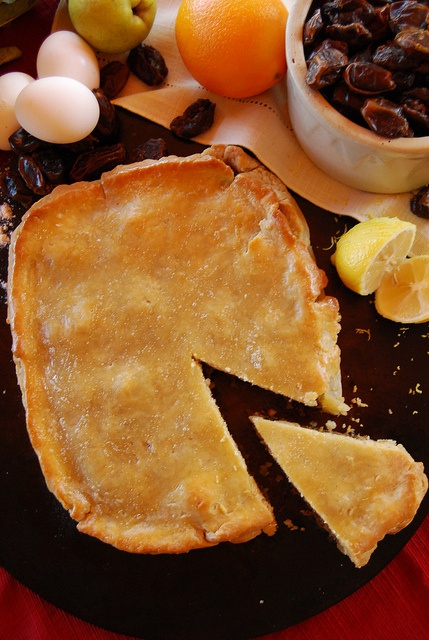Describe the objects in this image and their specific colors. I can see cake in black, red, tan, and orange tones, sandwich in black, red, tan, and orange tones, bowl in black, maroon, gray, and brown tones, sandwich in black, tan, and orange tones, and orange in black, red, brown, and orange tones in this image. 